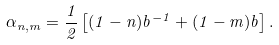Convert formula to latex. <formula><loc_0><loc_0><loc_500><loc_500>\alpha _ { n , m } = \frac { 1 } { 2 } \left [ ( 1 - n ) b ^ { - 1 } + ( 1 - m ) b \right ] .</formula> 